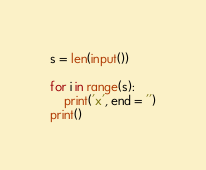Convert code to text. <code><loc_0><loc_0><loc_500><loc_500><_Python_>s = len(input())

for i in range(s):
	print('x', end = '')
print()</code> 